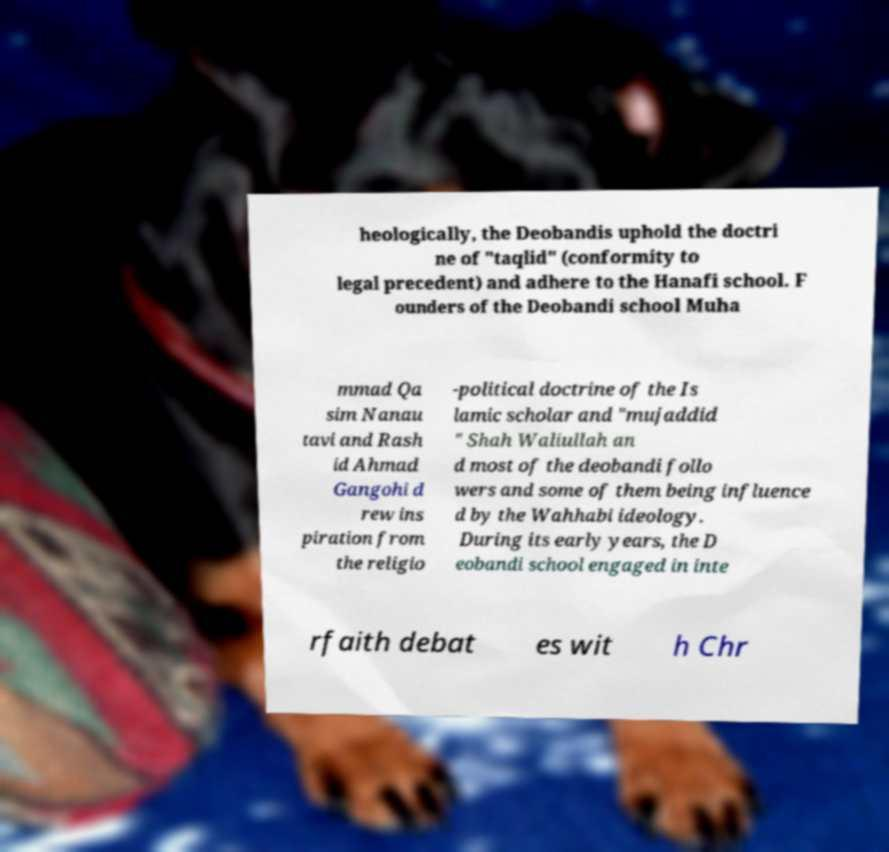Could you extract and type out the text from this image? heologically, the Deobandis uphold the doctri ne of "taqlid" (conformity to legal precedent) and adhere to the Hanafi school. F ounders of the Deobandi school Muha mmad Qa sim Nanau tavi and Rash id Ahmad Gangohi d rew ins piration from the religio -political doctrine of the Is lamic scholar and "mujaddid " Shah Waliullah an d most of the deobandi follo wers and some of them being influence d by the Wahhabi ideology. During its early years, the D eobandi school engaged in inte rfaith debat es wit h Chr 